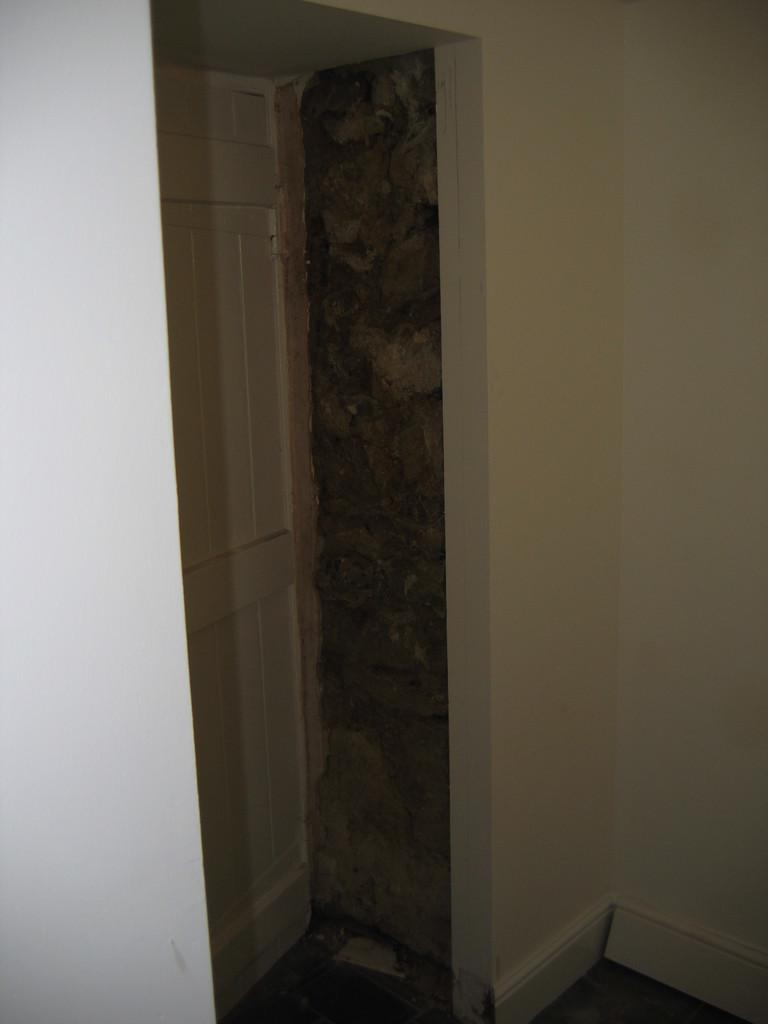What type of structure can be seen in the image? There is a wall in the image. What surface is visible beneath the wall? There is a floor in the image. Is there any entrance or exit visible in the image? Yes, there is a door in the image. How many apples are hanging from the wall in the image? There are no apples present in the image. What type of town is visible in the background of the image? There is no town visible in the image; it only features a wall, floor, and door. 